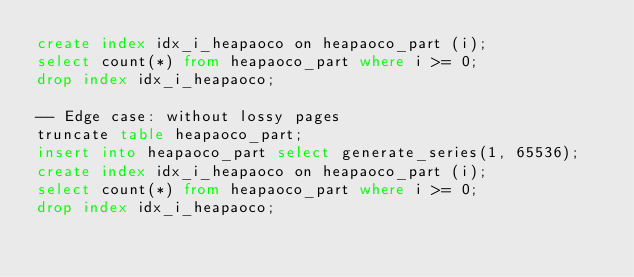<code> <loc_0><loc_0><loc_500><loc_500><_SQL_>create index idx_i_heapaoco on heapaoco_part (i);
select count(*) from heapaoco_part where i >= 0;
drop index idx_i_heapaoco;

-- Edge case: without lossy pages
truncate table heapaoco_part;
insert into heapaoco_part select generate_series(1, 65536);
create index idx_i_heapaoco on heapaoco_part (i);
select count(*) from heapaoco_part where i >= 0;
drop index idx_i_heapaoco;
</code> 